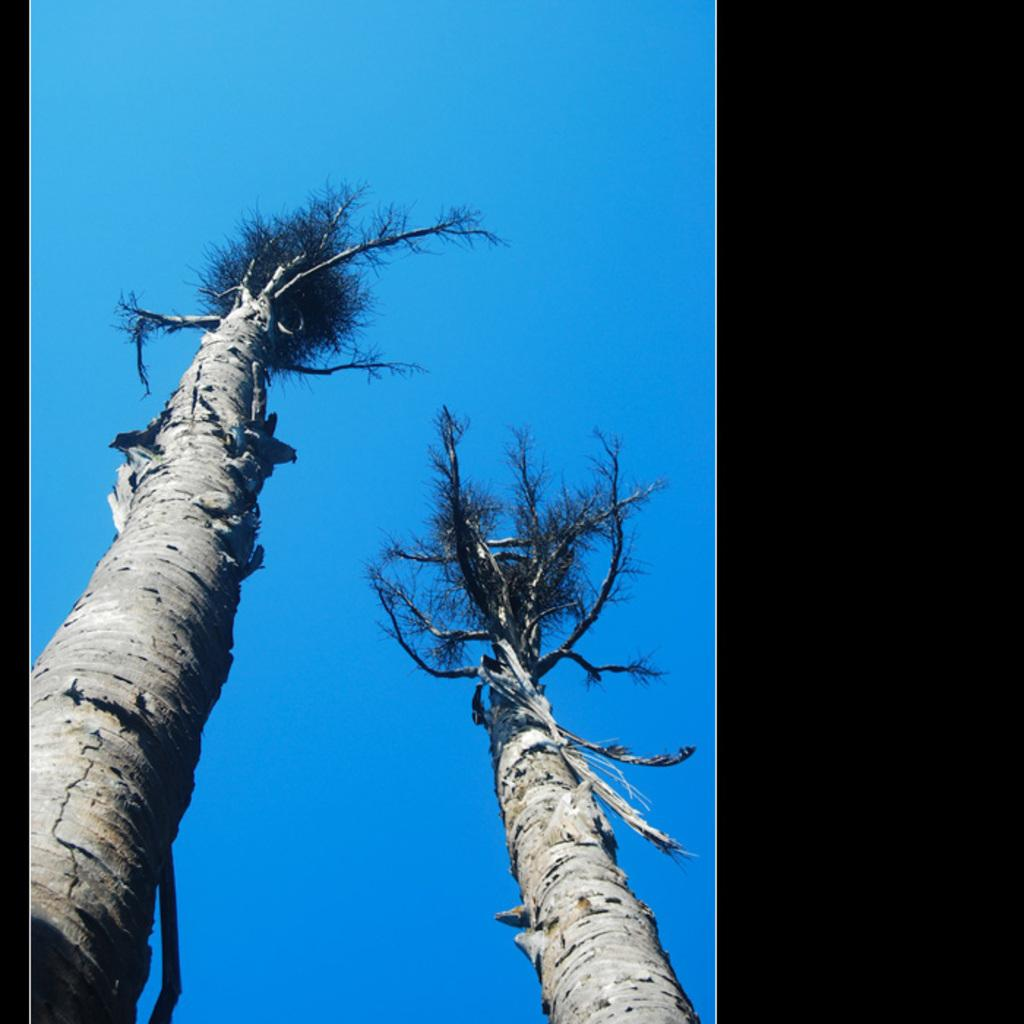What type of natural objects can be seen in the image? There are tree trunks in the image. What can be seen in the background of the image? The sky is visible in the background of the image. How many rays of sand can be seen in the image? There are no rays of sand present in the image; it features tree trunks and a sky background. 